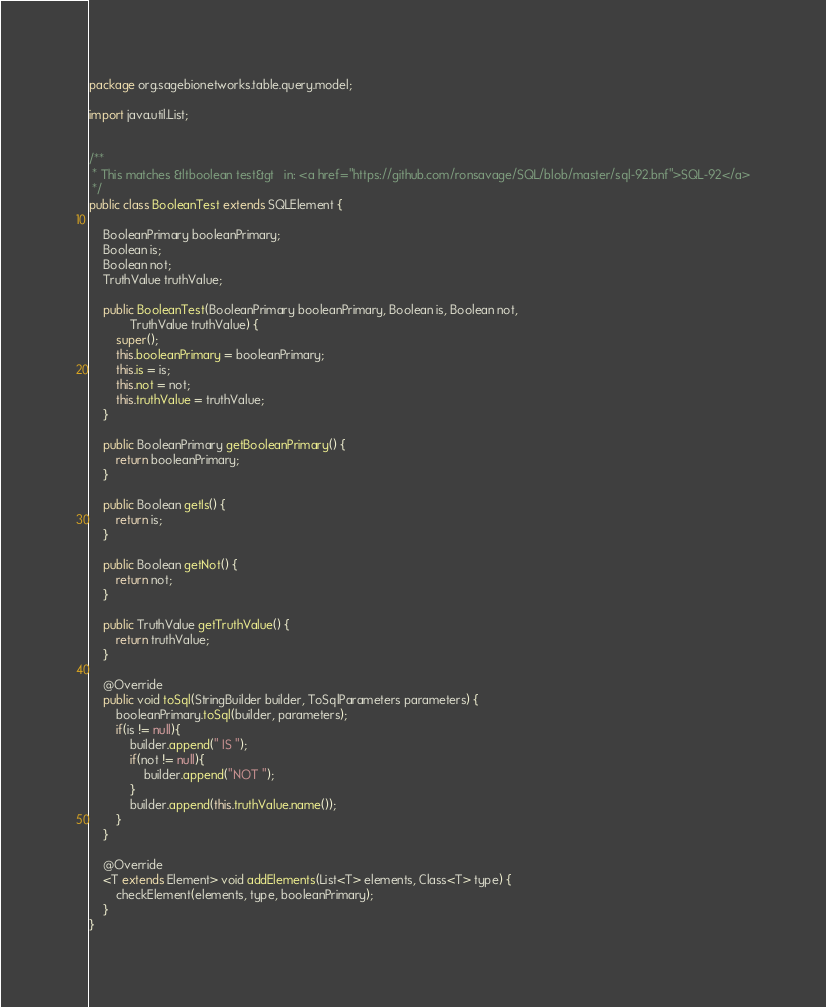<code> <loc_0><loc_0><loc_500><loc_500><_Java_>package org.sagebionetworks.table.query.model;

import java.util.List;


/**
 * This matches &ltboolean test&gt   in: <a href="https://github.com/ronsavage/SQL/blob/master/sql-92.bnf">SQL-92</a>
 */
public class BooleanTest extends SQLElement {

	BooleanPrimary booleanPrimary;
	Boolean is;
	Boolean not;
	TruthValue truthValue;
	
	public BooleanTest(BooleanPrimary booleanPrimary, Boolean is, Boolean not,
			TruthValue truthValue) {
		super();
		this.booleanPrimary = booleanPrimary;
		this.is = is;
		this.not = not;
		this.truthValue = truthValue;
	}

	public BooleanPrimary getBooleanPrimary() {
		return booleanPrimary;
	}

	public Boolean getIs() {
		return is;
	}

	public Boolean getNot() {
		return not;
	}

	public TruthValue getTruthValue() {
		return truthValue;
	}
	
	@Override
	public void toSql(StringBuilder builder, ToSqlParameters parameters) {
		booleanPrimary.toSql(builder, parameters);
		if(is != null){
			builder.append(" IS ");
			if(not != null){
				builder.append("NOT ");
			}
			builder.append(this.truthValue.name());
		}
	}

	@Override
	<T extends Element> void addElements(List<T> elements, Class<T> type) {
		checkElement(elements, type, booleanPrimary);
	}
}
</code> 